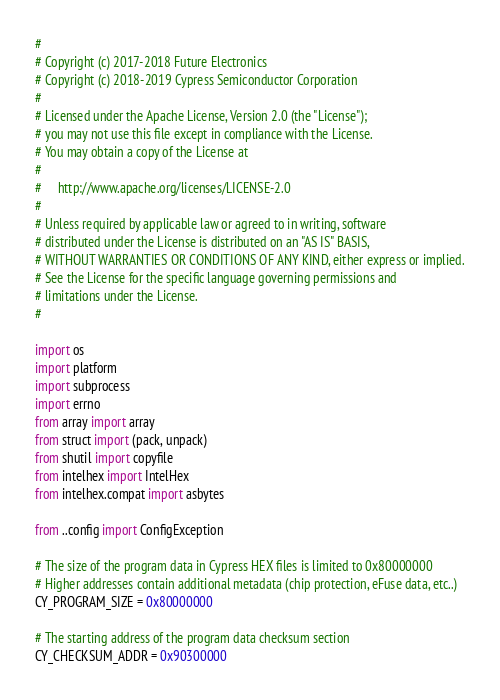<code> <loc_0><loc_0><loc_500><loc_500><_Python_>#
# Copyright (c) 2017-2018 Future Electronics
# Copyright (c) 2018-2019 Cypress Semiconductor Corporation
#
# Licensed under the Apache License, Version 2.0 (the "License");
# you may not use this file except in compliance with the License.
# You may obtain a copy of the License at
#
#     http://www.apache.org/licenses/LICENSE-2.0
#
# Unless required by applicable law or agreed to in writing, software
# distributed under the License is distributed on an "AS IS" BASIS,
# WITHOUT WARRANTIES OR CONDITIONS OF ANY KIND, either express or implied.
# See the License for the specific language governing permissions and
# limitations under the License.
#

import os
import platform
import subprocess
import errno
from array import array
from struct import (pack, unpack)
from shutil import copyfile
from intelhex import IntelHex
from intelhex.compat import asbytes

from ..config import ConfigException

# The size of the program data in Cypress HEX files is limited to 0x80000000
# Higher addresses contain additional metadata (chip protection, eFuse data, etc..)
CY_PROGRAM_SIZE = 0x80000000

# The starting address of the program data checksum section
CY_CHECKSUM_ADDR = 0x90300000
</code> 